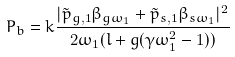Convert formula to latex. <formula><loc_0><loc_0><loc_500><loc_500>P _ { b } = k \frac { | \tilde { p } _ { g , 1 } \beta _ { g \omega _ { 1 } } + \tilde { p } _ { s , 1 } \beta _ { s \omega _ { 1 } } | ^ { 2 } } { 2 \omega _ { 1 } ( l + g ( \gamma \omega _ { 1 } ^ { 2 } - 1 ) ) }</formula> 